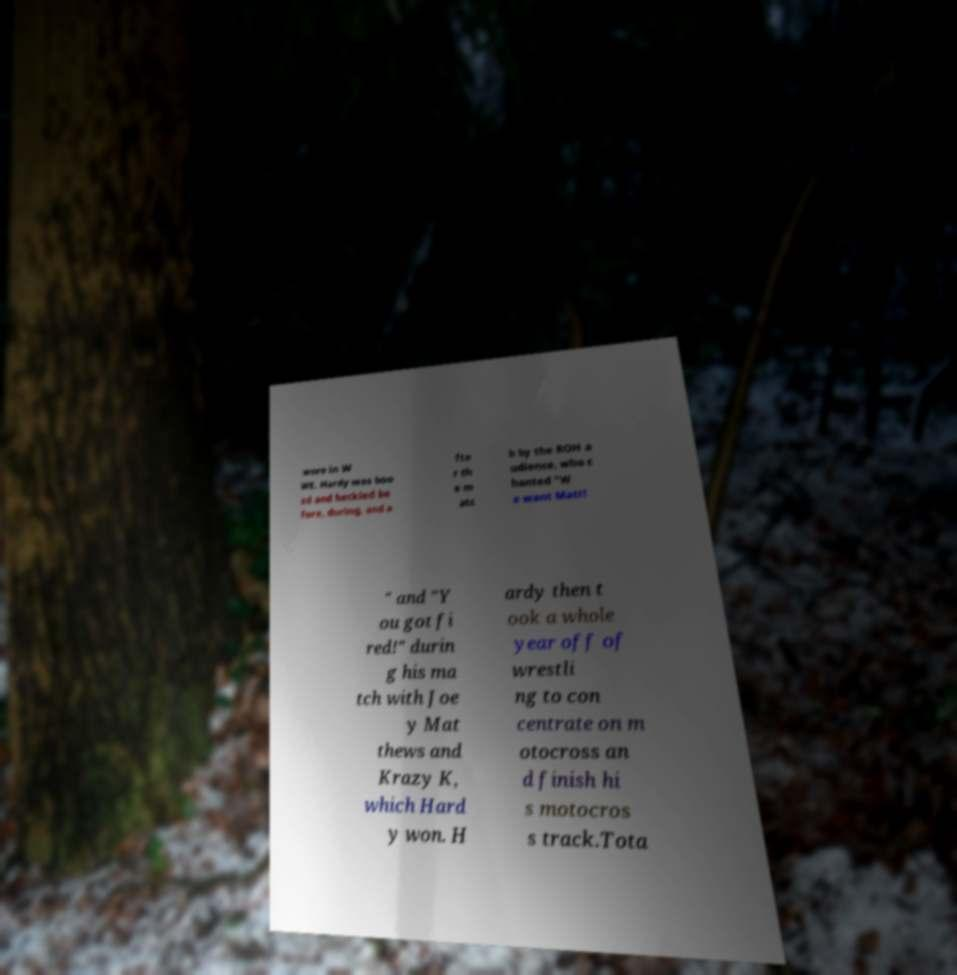There's text embedded in this image that I need extracted. Can you transcribe it verbatim? wore in W WE. Hardy was boo ed and heckled be fore, during, and a fte r th e m atc h by the ROH a udience, who c hanted "W e want Matt! " and "Y ou got fi red!" durin g his ma tch with Joe y Mat thews and Krazy K, which Hard y won. H ardy then t ook a whole year off of wrestli ng to con centrate on m otocross an d finish hi s motocros s track.Tota 